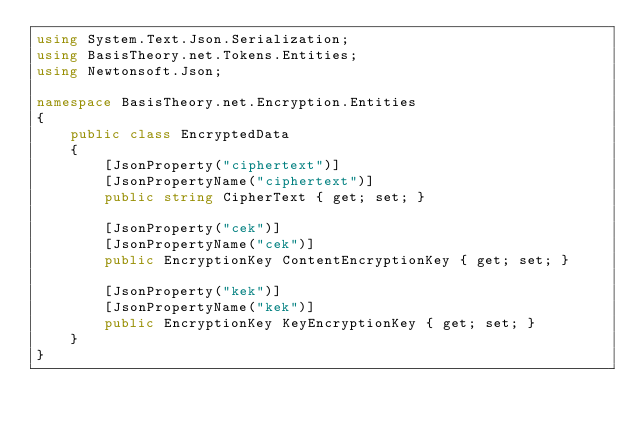<code> <loc_0><loc_0><loc_500><loc_500><_C#_>using System.Text.Json.Serialization;
using BasisTheory.net.Tokens.Entities;
using Newtonsoft.Json;

namespace BasisTheory.net.Encryption.Entities
{
    public class EncryptedData
    {
        [JsonProperty("ciphertext")]
        [JsonPropertyName("ciphertext")]
        public string CipherText { get; set; }

        [JsonProperty("cek")]
        [JsonPropertyName("cek")]
        public EncryptionKey ContentEncryptionKey { get; set; }

        [JsonProperty("kek")]
        [JsonPropertyName("kek")]
        public EncryptionKey KeyEncryptionKey { get; set; }
    }
}
</code> 